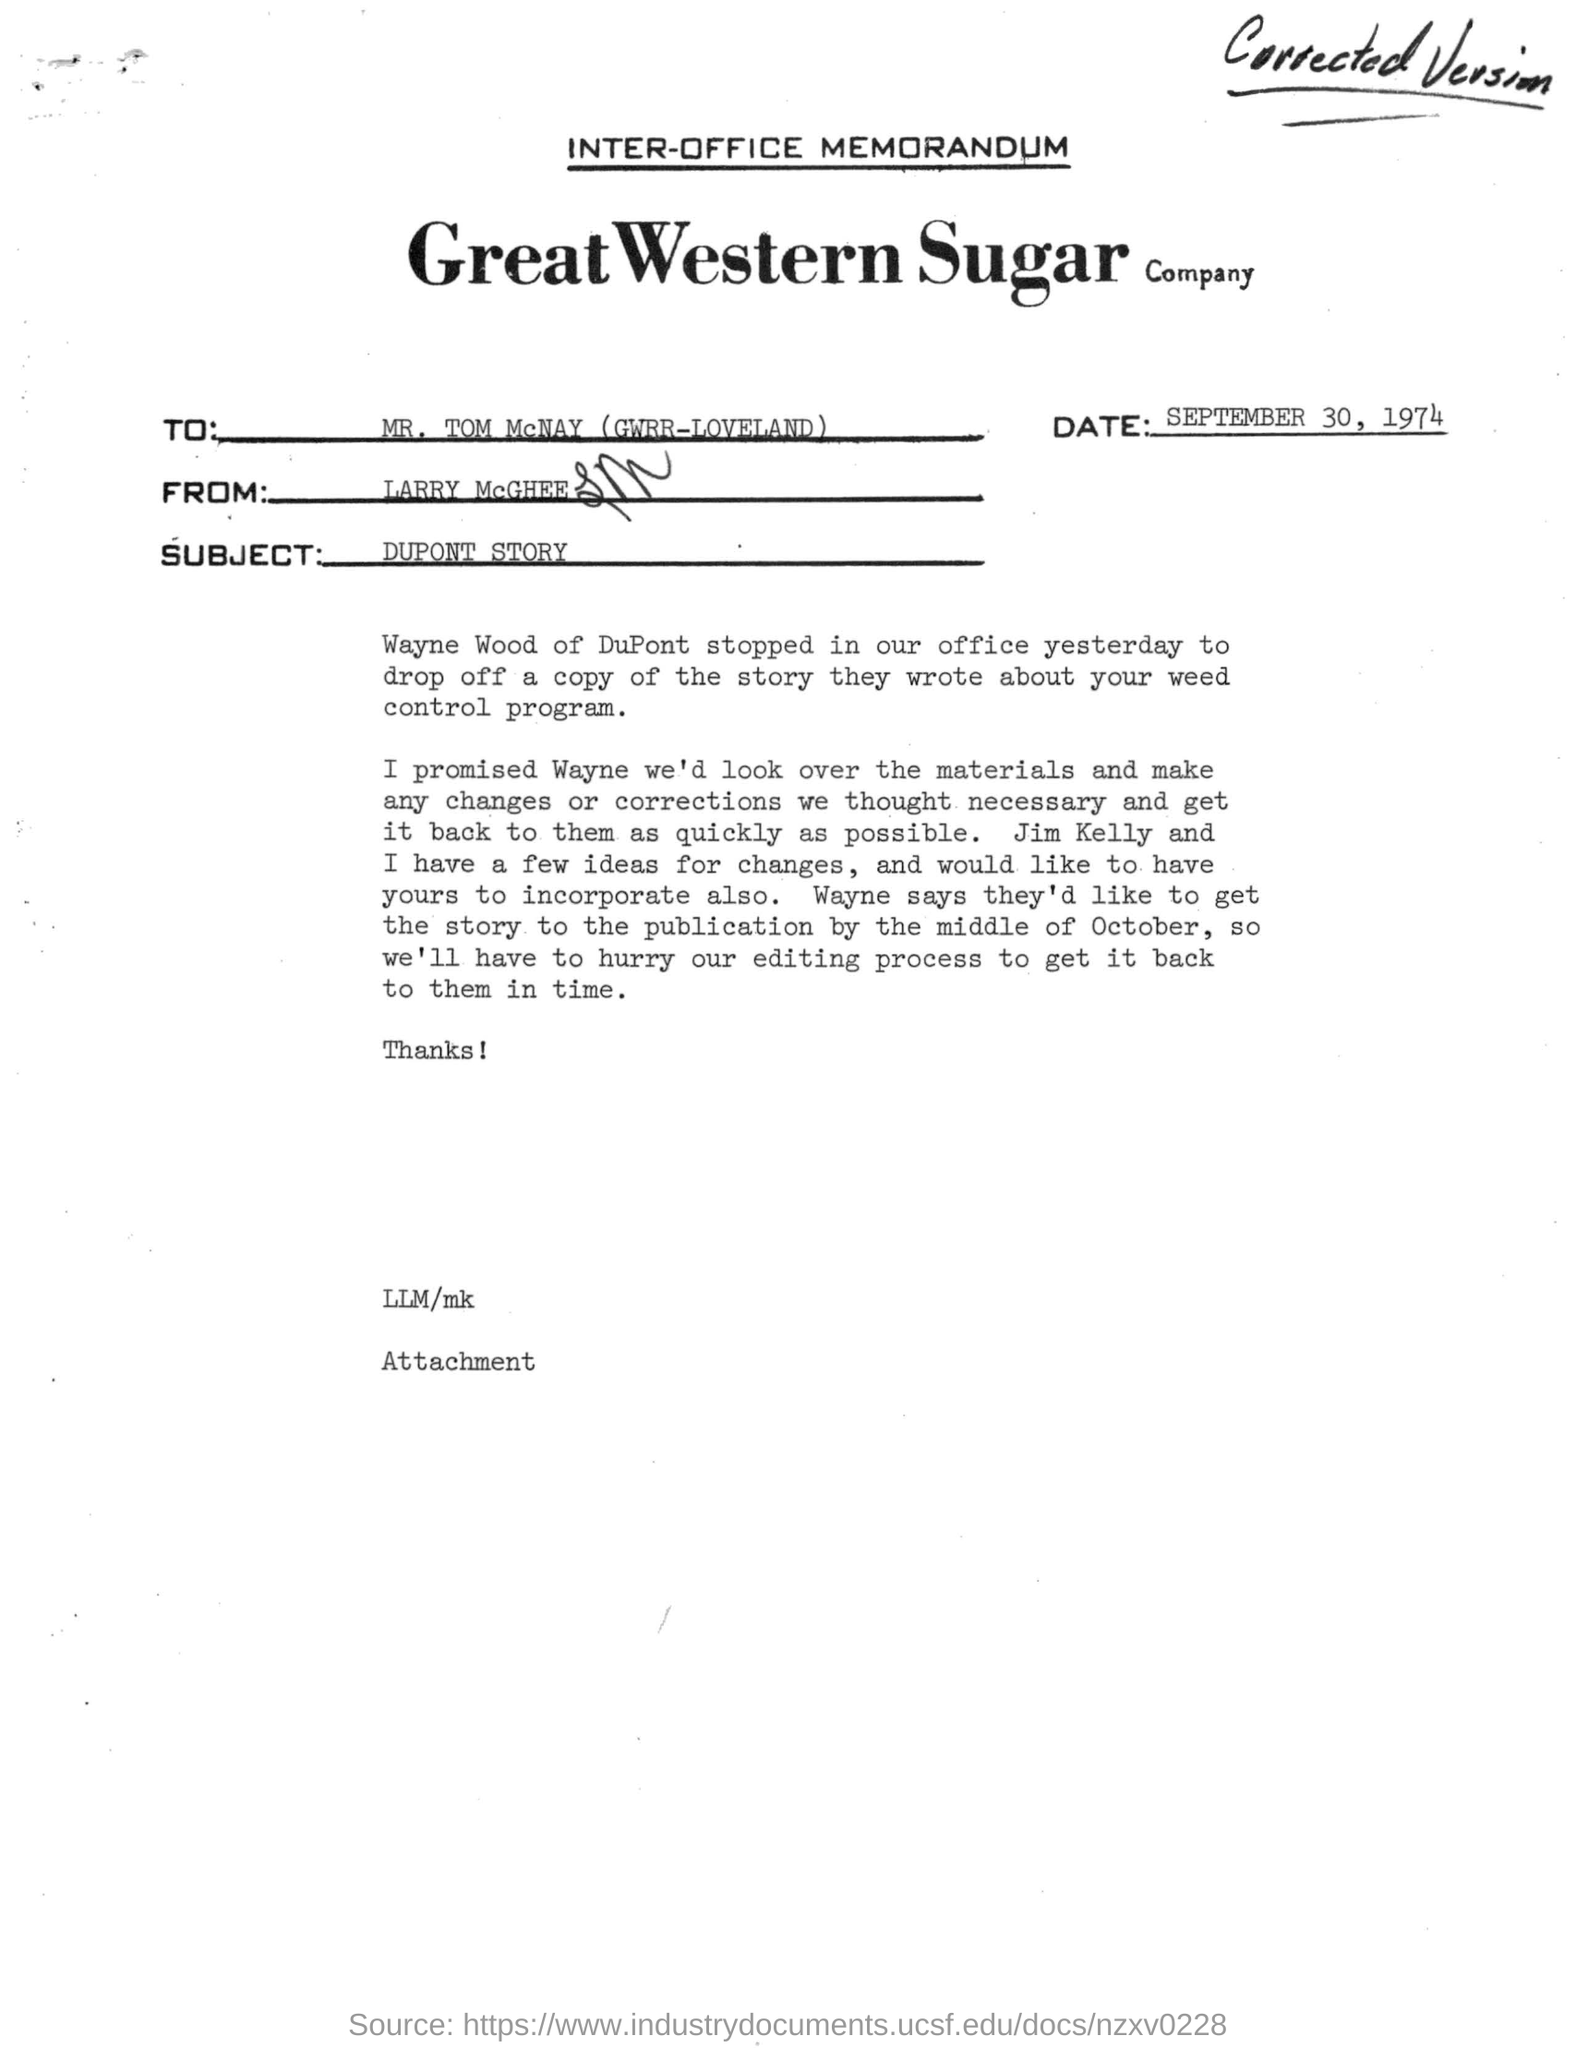When letter is dated on ?
Your response must be concise. September 30, 1974. What is the subject of the inter-office memorandum?
Keep it short and to the point. DUPONT STORY. Who wrote inter memorandum to mr. tom mcnay ?
Keep it short and to the point. Larry Mcghee. Who says that they'd like to get the story to the publication by the october?
Offer a very short reply. Wayne. 